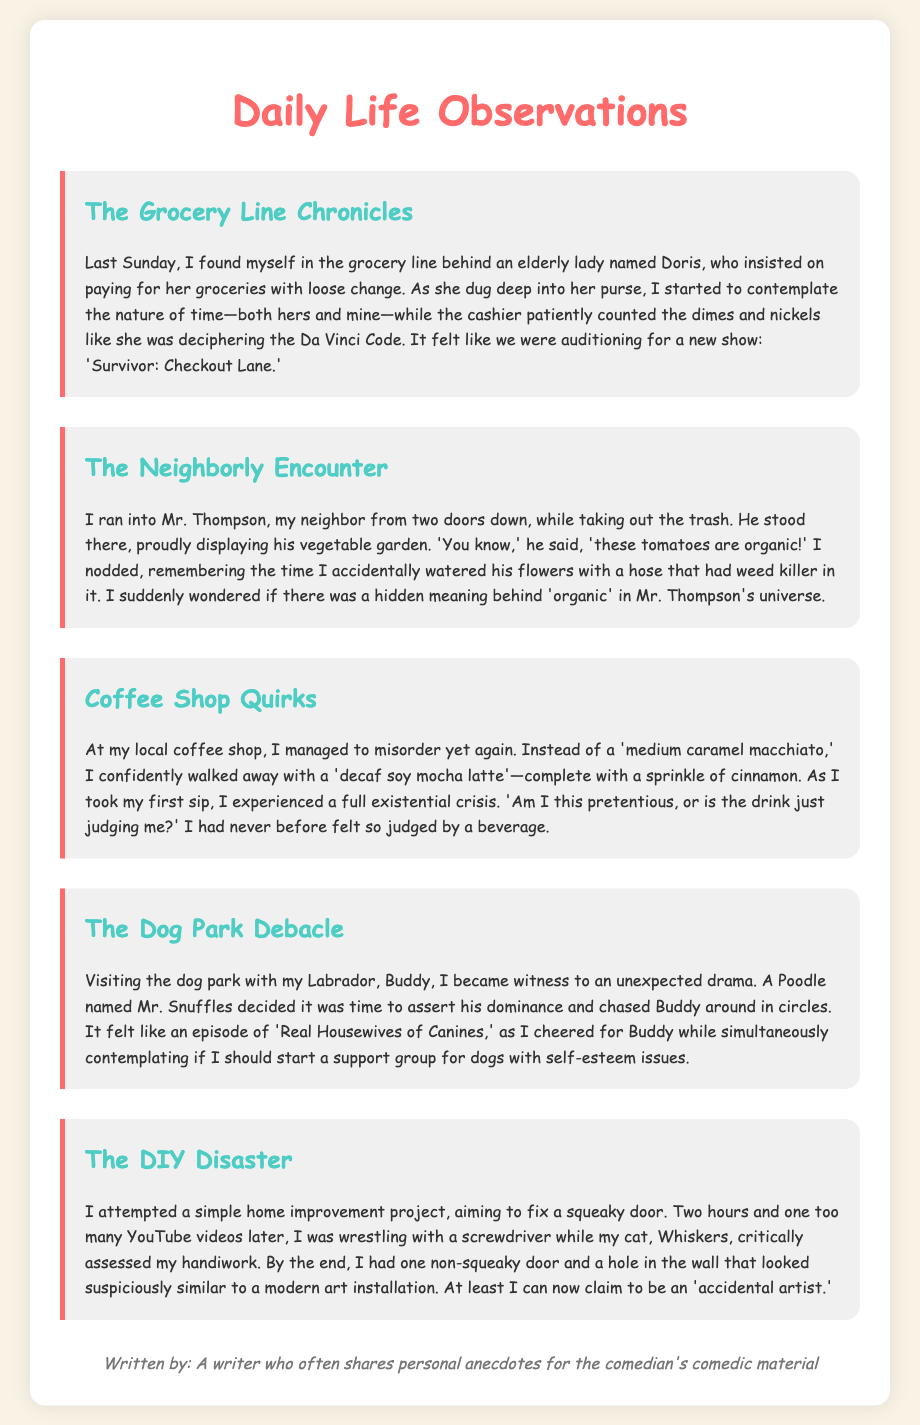What is the title of the document? The title is found in the header of the document, which introduces the content of the catalog.
Answer: Daily Life Observations Who is the writer of the anecdotes? The writer's information is provided at the bottom of the document.
Answer: A writer who often shares personal anecdotes for the comedian's comedic material What is the first anecdote about? The first anecdote's title indicates its subject matter, highlighting the specific event discussed.
Answer: The Grocery Line Chronicles How many anecdotes are listed in the document? The document contains a series of separate anecdotes, each marked as an observation.
Answer: Five What was the unexpected encounter involving Mr. Thompson? The anecdote describes a specific interaction and includes a particular detail regarding Mr. Thompson's pride.
Answer: His vegetable garden What drink did the writer accidentally order? The specific drink mentioned reflects the writer's humorous misordering experience at a coffee shop.
Answer: Decaf soy mocha latte What does the writer contemplate while at the dog park? The commentary during the dog park visit hints at a deeper reflection about a societal issue related to pets.
Answer: A support group for dogs with self-esteem issues Which animal assessed the writer's home improvement project? A reference to the writer's pet adds a humorous element to the home improvement anecdote.
Answer: Cat What type of art does the writer claim to create by accident? The conclusion of the DIY Disaster anecdote suggests a playful take on the outcome of the project.
Answer: Modern art installation 